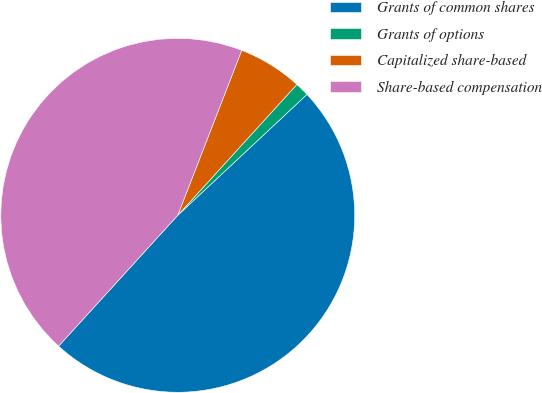Convert chart to OTSL. <chart><loc_0><loc_0><loc_500><loc_500><pie_chart><fcel>Grants of common shares<fcel>Grants of options<fcel>Capitalized share-based<fcel>Share-based compensation<nl><fcel>48.73%<fcel>1.27%<fcel>5.87%<fcel>44.13%<nl></chart> 